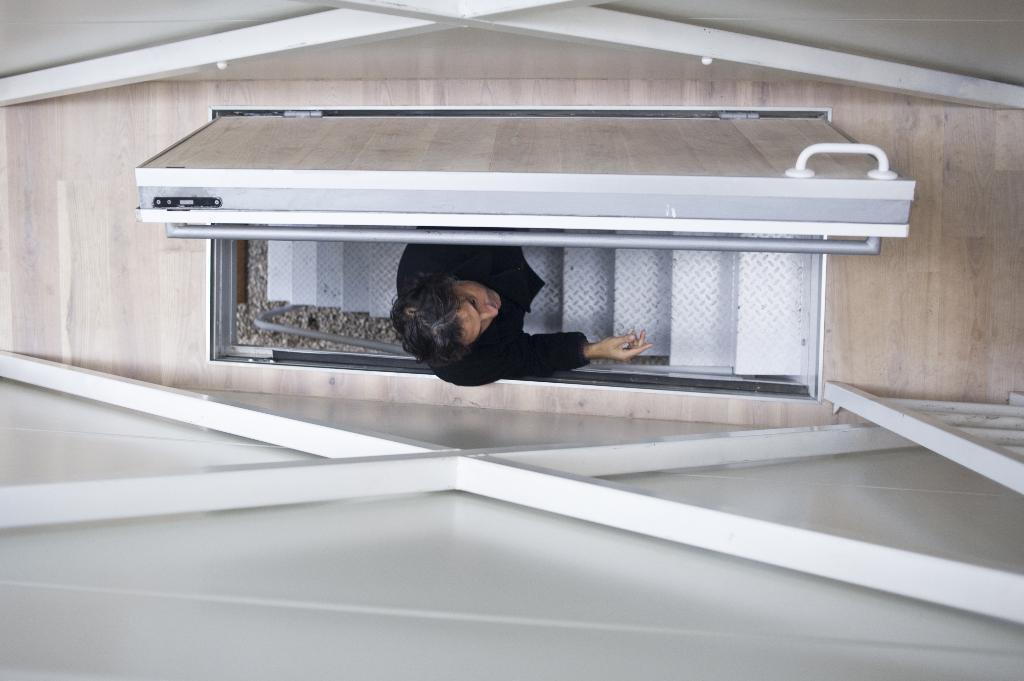Describe this image in one or two sentences. In this image I can see the person with the black color dress and the person is standing on the stairs. To the side of the person I can see the door. On both sides I can see the wall. To the right I can see the ladder. 